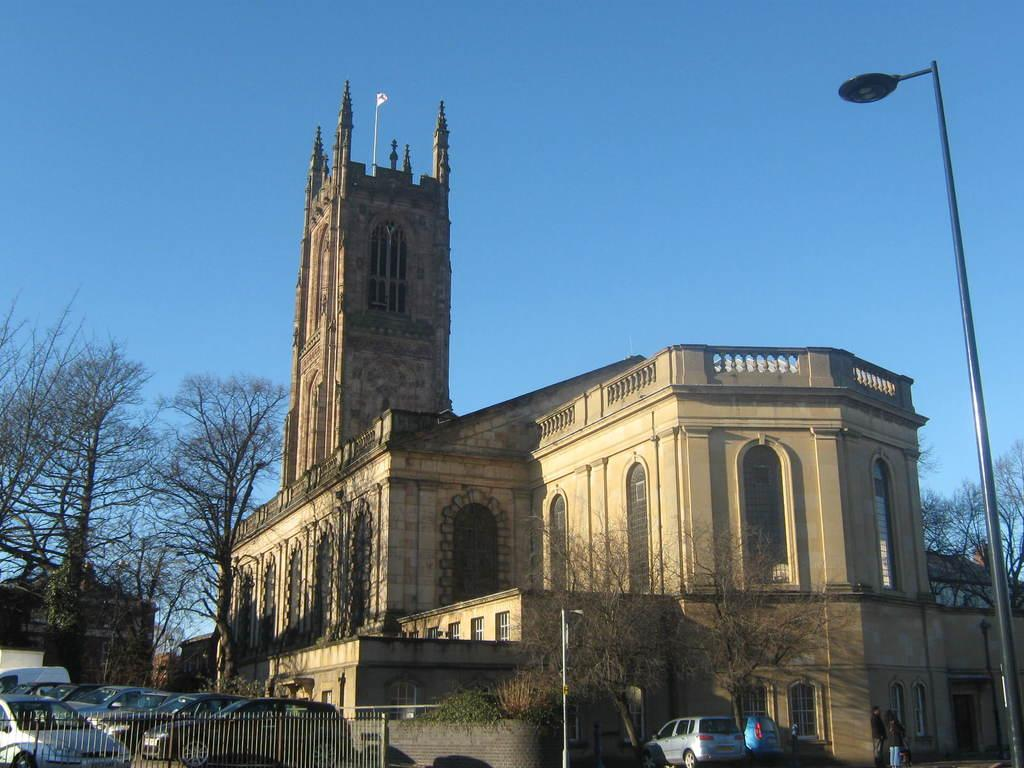What can be seen in the foreground of the image? In the foreground of the image, there is a railing, cars parked, poles, and trees. Can you describe the background of the image? In the background of the image, there is a building, a flag, trees, and the sky is visible. How many elements are present in the foreground of the image? There are four elements present in the foreground: a railing, cars parked, poles, and trees. What type of structure is visible in the background of the image? There is a building visible in the background of the image. What type of tin can be seen being processed in the image? There is no tin or any indication of an industry in the image. How many steps are visible in the image? There are no steps present in the image. 